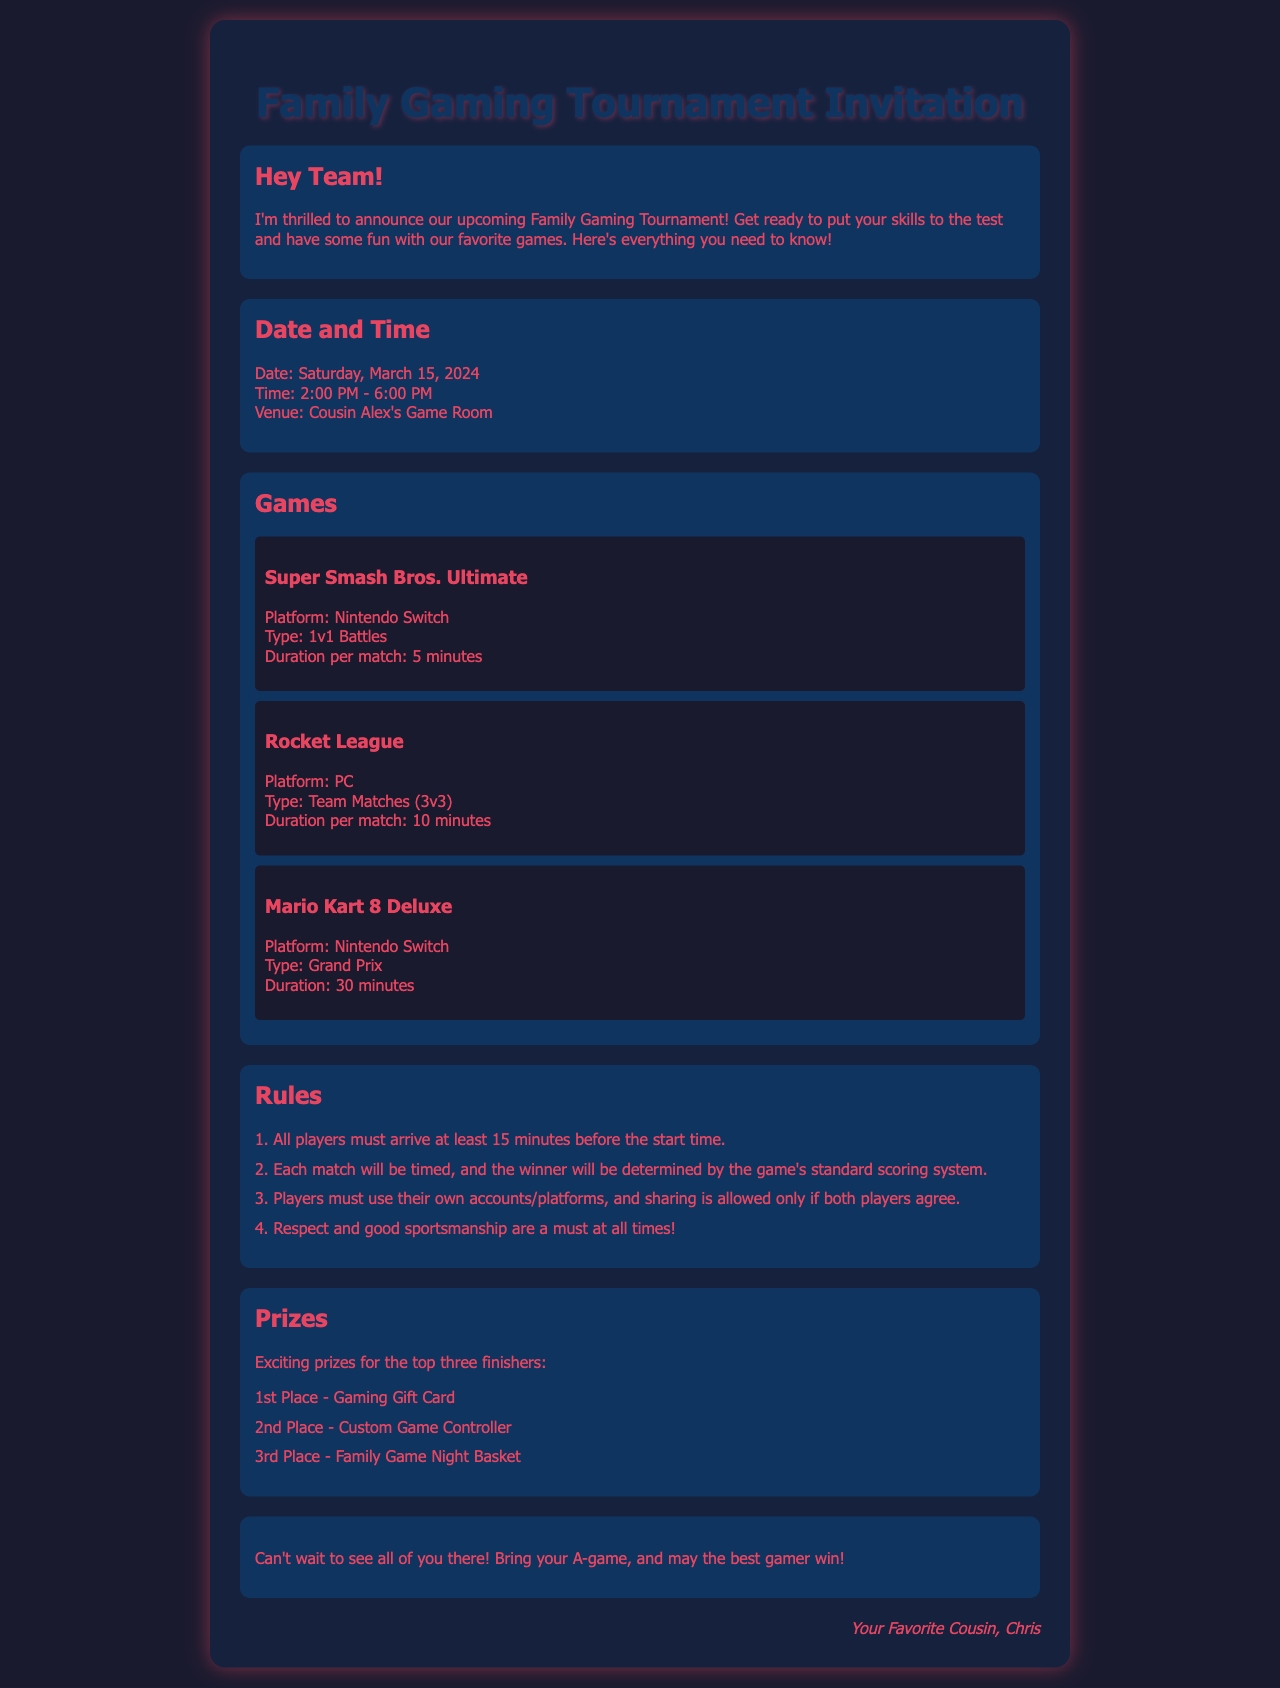What is the date of the tournament? The document specifies the tournament date, which is Saturday, March 15, 2024.
Answer: Saturday, March 15, 2024 What is the time of the tournament? The document states that the tournament will take place from 2:00 PM to 6:00 PM.
Answer: 2:00 PM - 6:00 PM How many games are being played? The document lists three games for the tournament: Super Smash Bros. Ultimate, Rocket League, and Mario Kart 8 Deluxe.
Answer: Three What is the duration of a match in Super Smash Bros. Ultimate? The document indicates that the duration per match for Super Smash Bros. Ultimate is 5 minutes.
Answer: 5 minutes Who is hosting the tournament? The document mentions that the venue is Cousin Alex's Game Room, indicating Chris is organizing it.
Answer: Cousin Alex What is a requirement for players before the tournament starts? The rules mention that all players must arrive at least 15 minutes before the start time.
Answer: 15 minutes What prize does the 1st place winner receive? The document states that the first-place prize is a Gaming Gift Card.
Answer: Gaming Gift Card How many players are allowed in Rocket League matches? The document specifies that Rocket League will have team matches of 3v3 format, meaning six players total.
Answer: 3v3 What type of attitude is expected from players according to the rules? The rules emphasize that respect and good sportsmanship are mandatory at all times.
Answer: Good sportsmanship 